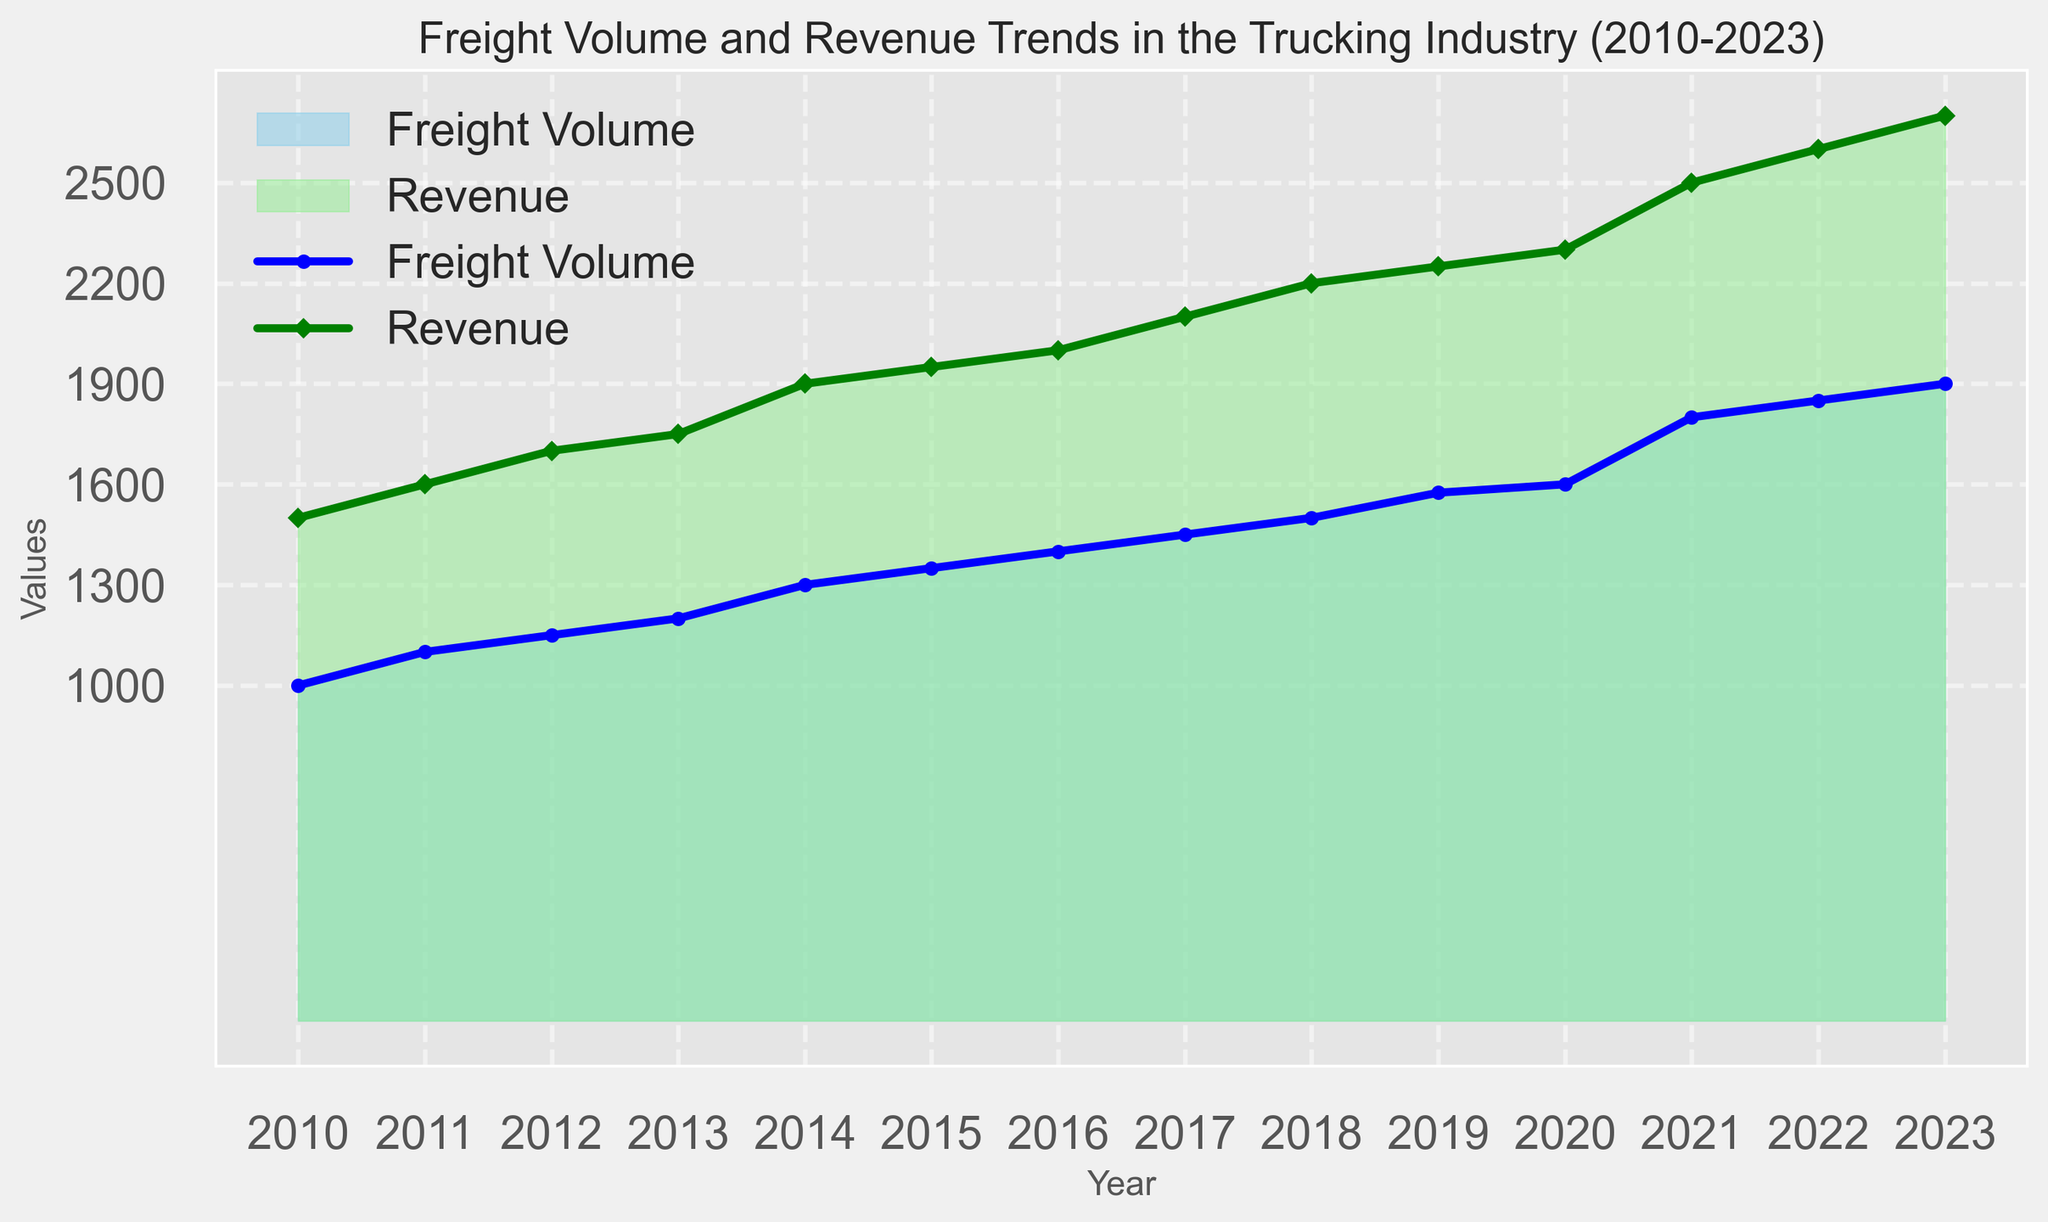What years saw an increase in the Freight Volume but a decrease in the Revenue? Examine the years on the x-axis where the Freight Volume curve increased while the Revenue curve decreased. Identify such years if any exist in the given range from 2010 to 2023. There are no years where Freight Volume increased and Revenue decreased; both metrics either increased or stayed constant each year.
Answer: None In which year did the Trucking Industry experience the highest increase in Revenue compared to the previous year, and what was the revenue in that year? Check the difference in Revenue values between consecutive years and find the year with the highest positive difference. The biggest jump in Revenue occurred from 2020 to 2021, moving from 2300 to 2500, an increase of 200.
Answer: 2021, 2500 What is the total sum of Freight Volume and Revenue for the year 2023? Add Freight Volume and Revenue for the year 2023. Freight Volume is 1900 and Revenue is 2700; thus, the total sum is 1900 + 2700 = 4600.
Answer: 4600 Between 2010 and 2023, in which year did Freight Volume and Revenue both exceed their values from the previous year by the same amount? Compare the year-by-year increments for both Freight Volume and Revenue and check for a year in which both increments are equal. In 2011, both increased by 100 compared to 2010.
Answer: 2011 What is the average Freight Volume from 2010 to 2023? Sum all Freight Volume values from 2010 to 2023 and divide by the number of years. The sum is (1000 + 1100 + 1150 + 1200 + 1300 + 1350 + 1400 + 1450 + 1500 + 1575 + 1600 + 1800 + 1850 + 1900). The total number of years is 14, so the average is 20075 / 14 ≈ 1434.
Answer: 1434 Which year marks the first time the Revenue crosses the 2000 threshold? Look at the Revenue values for each year and identify when the number exceeds 2000 for the first time. In 2016, the Revenue reaches 2000 and crosses it in 2017 with a value of 2100.
Answer: 2017 Compare the Freight Volume in 2020 to the Freight Volume in 2018. Which one is greater and by how much? Find Freight Volume values for 2020 (1600) and 2018 (1500) and calculate the difference. Freight Volume in 2020 is greater by 1600 - 1500 = 100.
Answer: 2020 by 100 What is the combined total of Freight Volume and Revenue for the years of 2010 and 2023? Add the Freight Volume and Revenue values for both 2010 and 2023. For 2010: 1000 + 1500 = 2500. For 2023: 1900 + 2700 = 4600. Total combined = 2500 + 4600 = 7100.
Answer: 7100 Which color represents the Revenue trend in the figure? Look at the plot legend and identify the color attributed to the Revenue. The legend states that the Revenue trend is marked by lightgreen.
Answer: lightgreen 